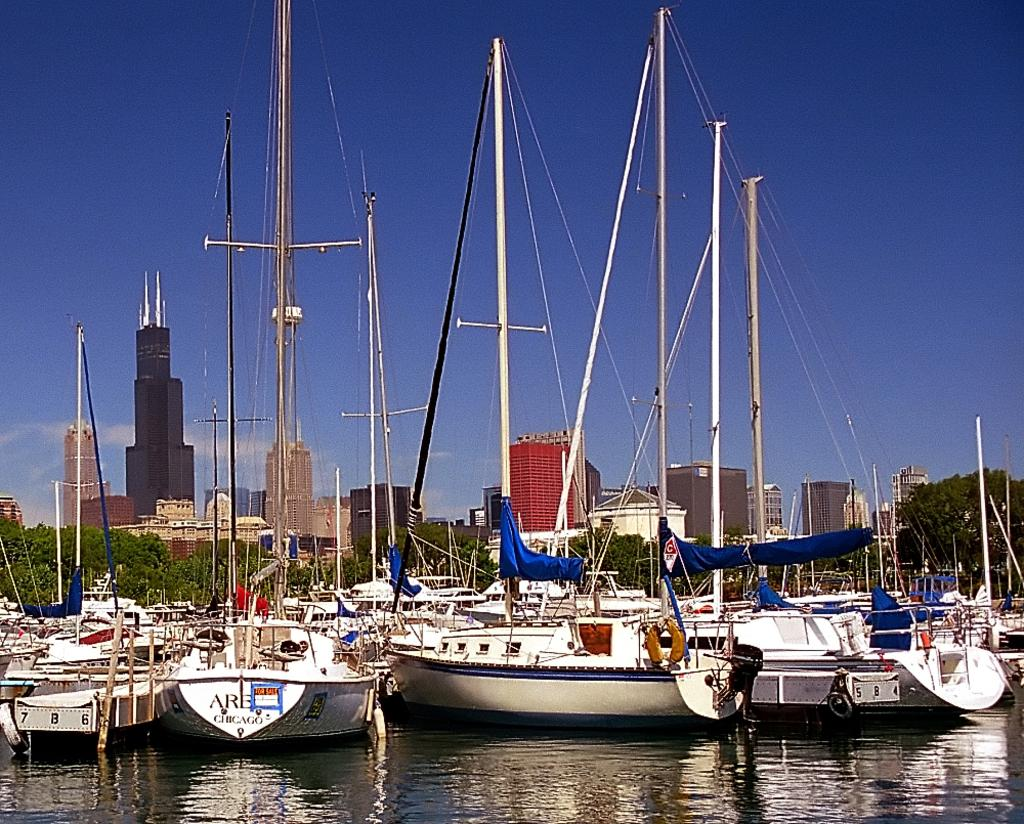Provide a one-sentence caption for the provided image. Boats sit in a marina and one with the word Chicago on the back also has a for sale sign on it. 